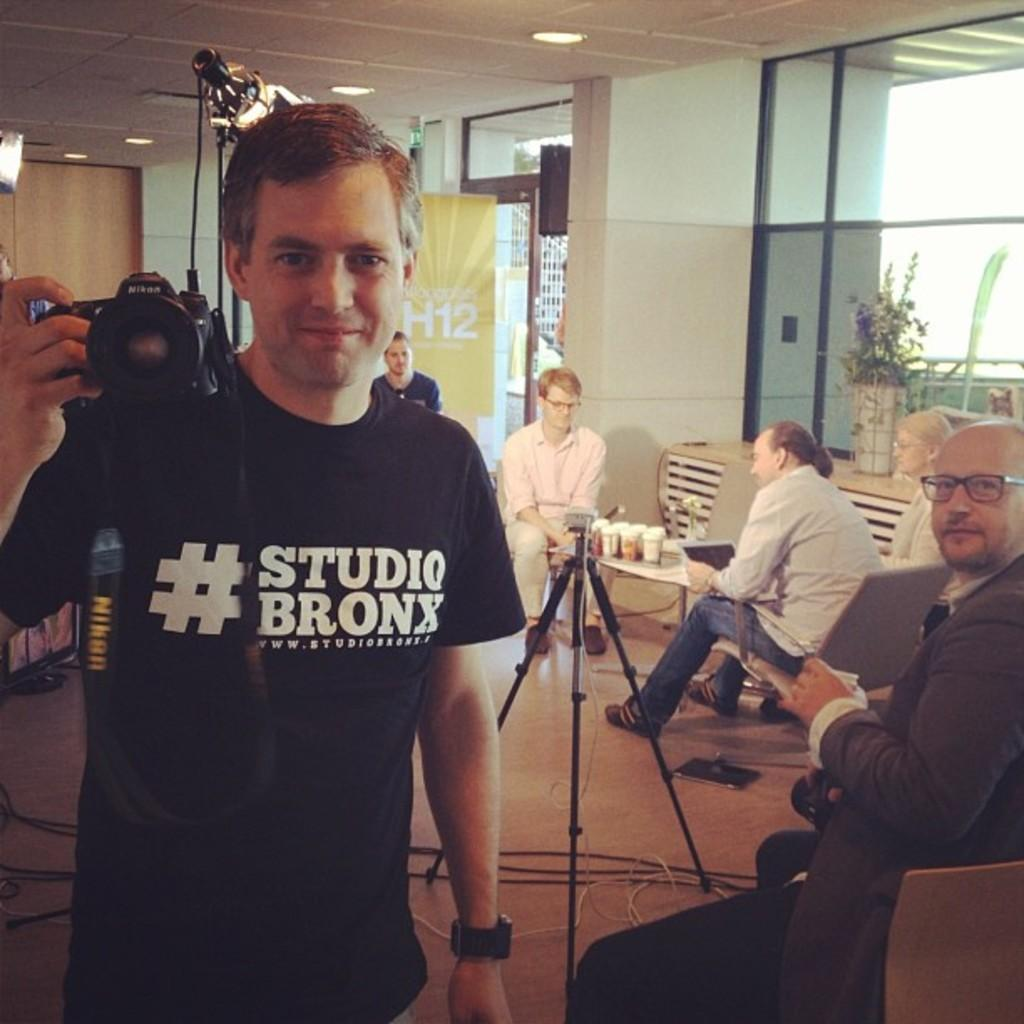What type of flooring is visible in the image? There are tiles in the image. What architectural feature can be seen in the image? There is a window in the image. What is the primary vertical structure in the image? There is a wall in the image. What are the people in the image doing? They are sitting on chairs in the image. What piece of furniture is present in the image? There is a table in the image. What objects are on the table? There are glasses on the table. What is the man in the image doing? The man is standing in the image and holding a camera. Can you tell me how many bears are visible in the image? There are no bears present in the image. What type of show is the man putting on for the people sitting on chairs? There is no show in the image; the man is simply holding a camera. 